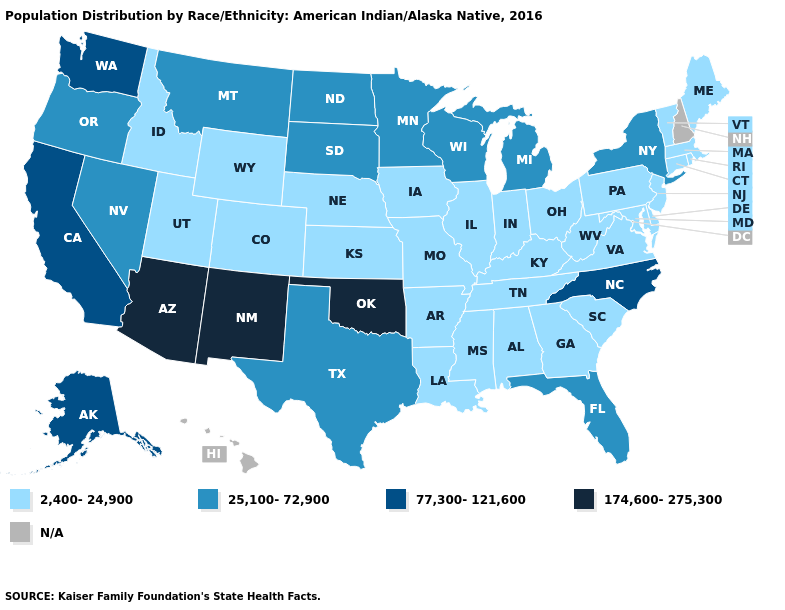Does New York have the lowest value in the Northeast?
Short answer required. No. How many symbols are there in the legend?
Short answer required. 5. Does North Carolina have the lowest value in the South?
Answer briefly. No. What is the value of Rhode Island?
Be succinct. 2,400-24,900. What is the value of Wyoming?
Concise answer only. 2,400-24,900. Which states hav the highest value in the MidWest?
Give a very brief answer. Michigan, Minnesota, North Dakota, South Dakota, Wisconsin. What is the value of Maine?
Short answer required. 2,400-24,900. What is the value of New Jersey?
Answer briefly. 2,400-24,900. What is the value of Texas?
Give a very brief answer. 25,100-72,900. Does Oklahoma have the highest value in the South?
Give a very brief answer. Yes. Does New Mexico have the lowest value in the West?
Concise answer only. No. Is the legend a continuous bar?
Quick response, please. No. What is the value of Mississippi?
Give a very brief answer. 2,400-24,900. Name the states that have a value in the range 25,100-72,900?
Write a very short answer. Florida, Michigan, Minnesota, Montana, Nevada, New York, North Dakota, Oregon, South Dakota, Texas, Wisconsin. 